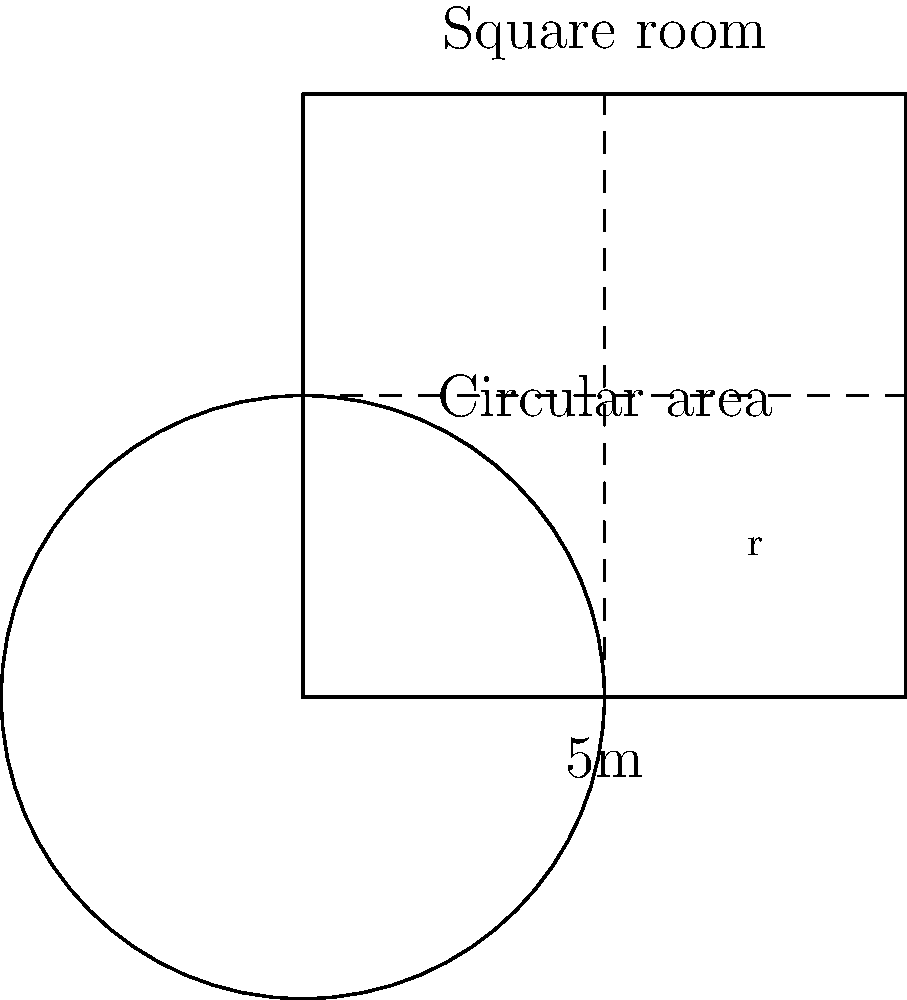In a virtual reality sustainable design project, you're optimizing a square room layout for energy efficiency. The room is 5m x 5m, with a circular area in the center for a heat source. If the circular area should cover 25% of the room's total area, what should be the radius of the circle to the nearest centimeter? Let's approach this step-by-step:

1) First, calculate the area of the square room:
   $A_{square} = 5m \times 5m = 25m^2$

2) The circular area should cover 25% of the total area:
   $A_{circle} = 25\% \times 25m^2 = 0.25 \times 25m^2 = 6.25m^2$

3) Now, we need to find the radius of this circle. The formula for the area of a circle is:
   $A = \pi r^2$

4) Substituting our known area:
   $6.25m^2 = \pi r^2$

5) Solving for r:
   $r^2 = \frac{6.25m^2}{\pi}$
   $r = \sqrt{\frac{6.25m^2}{\pi}}$

6) Calculate:
   $r = \sqrt{\frac{6.25}{3.14159}} \approx 1.4105m$

7) Rounding to the nearest centimeter:
   $r \approx 1.41m$

Therefore, the radius of the circular area should be 1.41m or 141cm.
Answer: 141 cm 